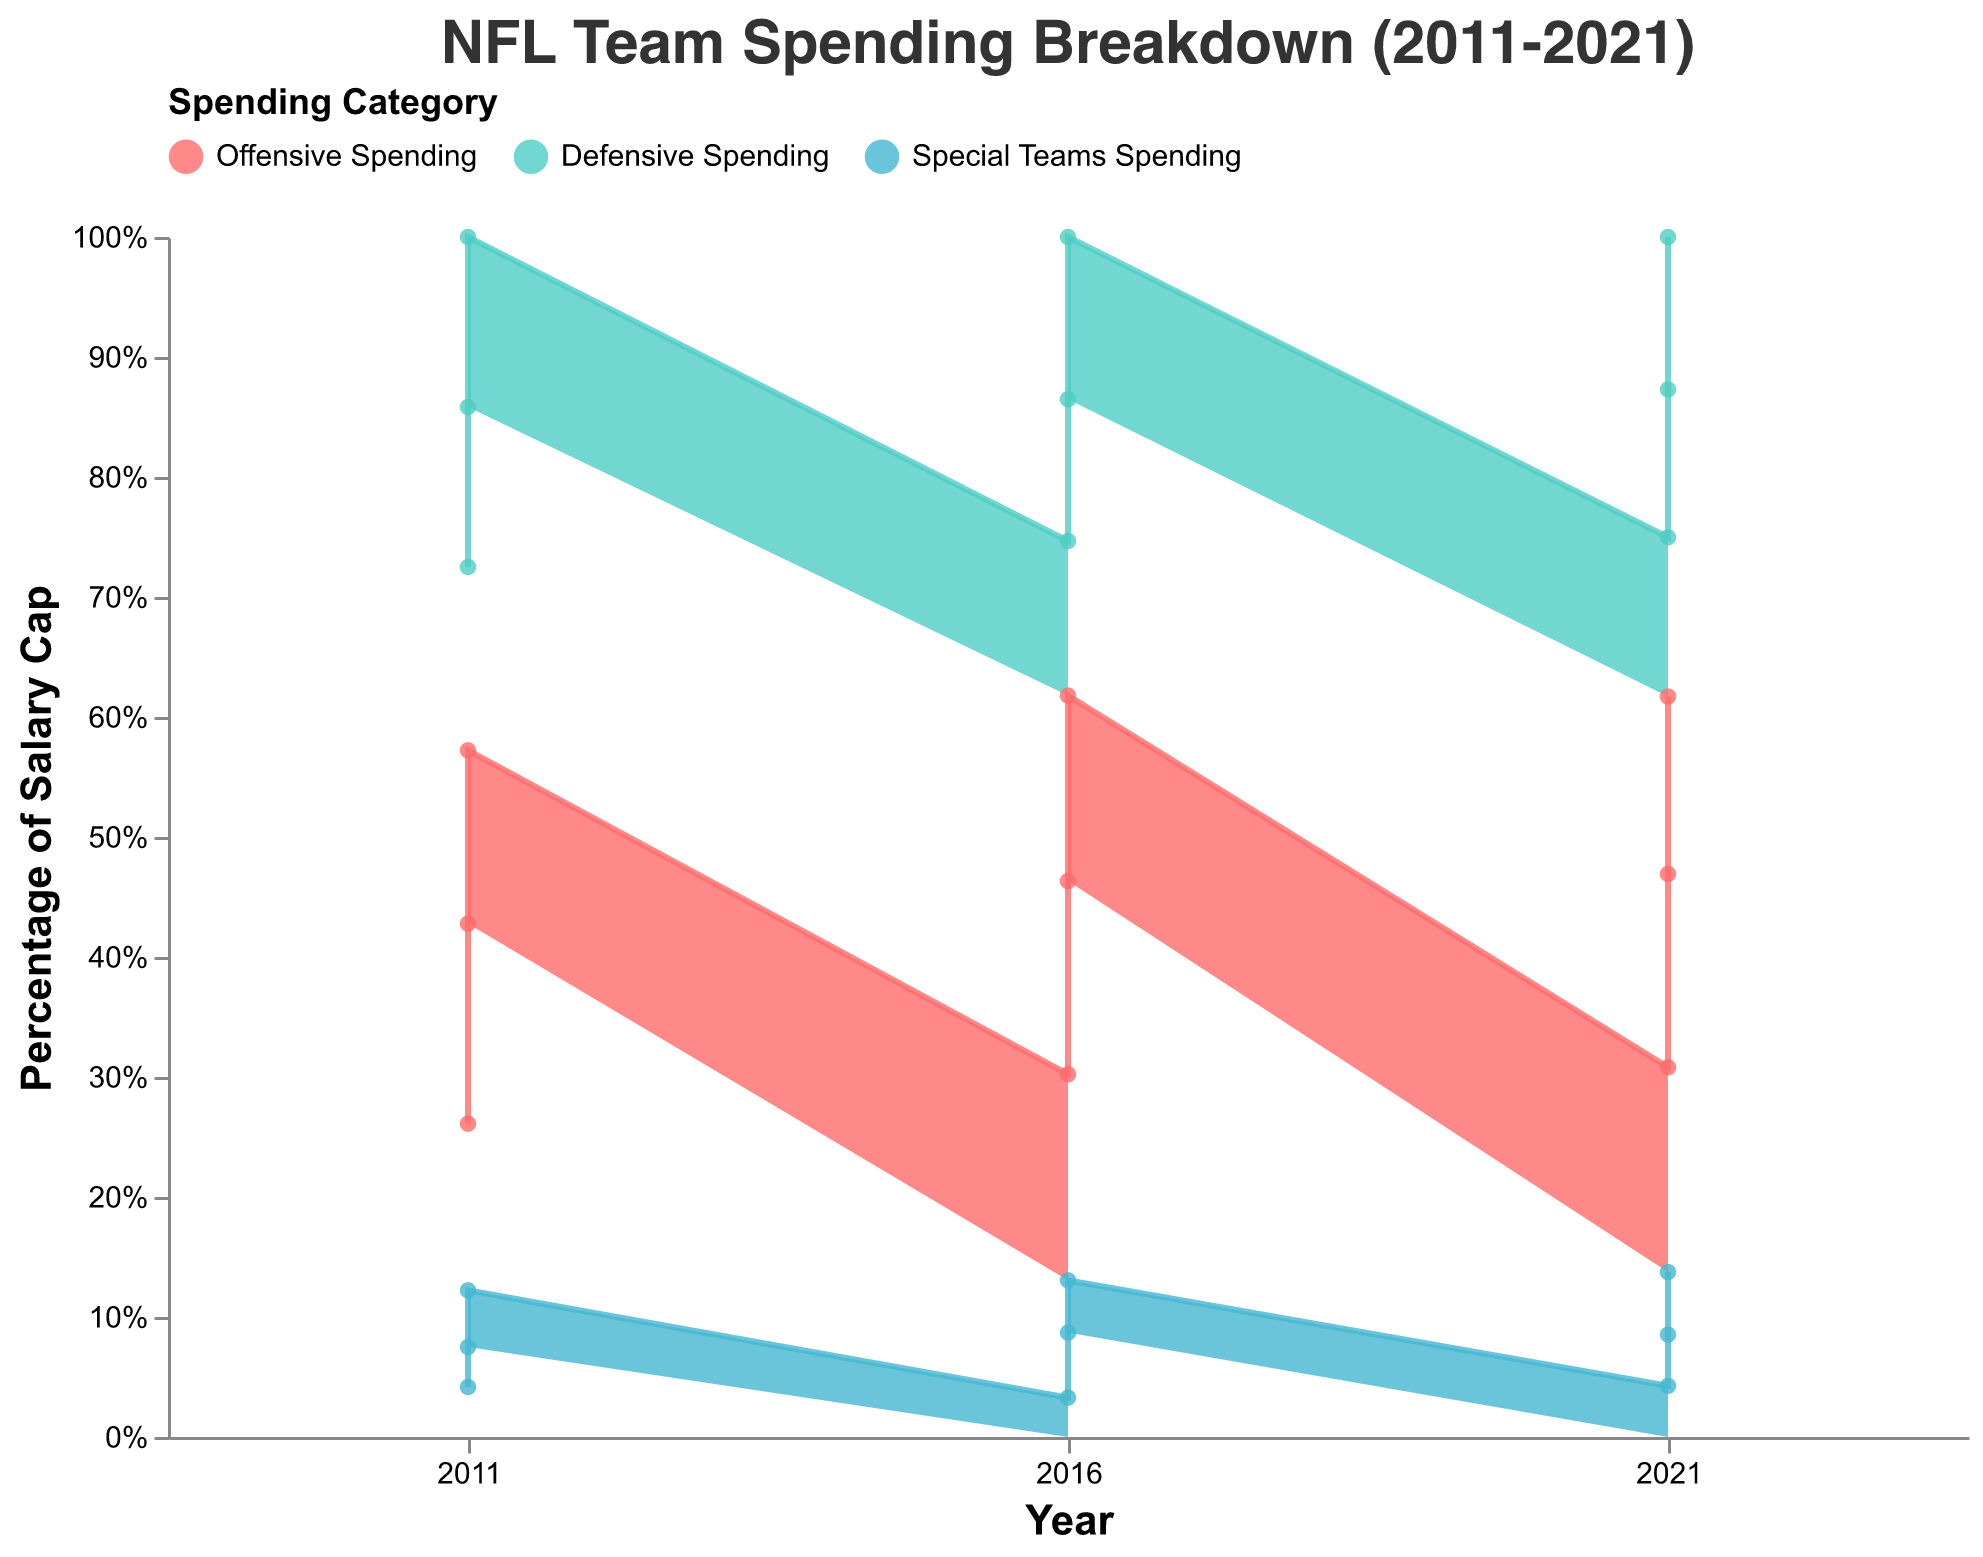What's the title of the chart? The title is typically displayed at the top of the chart. In this figure, the title is "NFL Team Spending Breakdown (2011-2021)."
Answer: NFL Team Spending Breakdown (2011-2021) What are the three spending categories shown in the chart? The legend indicates the three spending categories by color. The categories are Offensive Spending (red), Defensive Spending (green), and Special Teams Spending (blue).
Answer: Offensive Spending, Defensive Spending, Special Teams Spending Which team had the highest special teams spending in 2021? Look at the 2021 data points and compare the heights of the blue (Special Teams Spending) areas for each team. The highest point is for the Green Bay Packers.
Answer: Green Bay Packers How does the percentage of offensive spending change for Dallas Cowboys from 2011 to 2021? Identify the red (Offensive Spending) sections for the Dallas Cowboys in 2011 and 2021. The percentage of offensive spending increases from 41.67% in 2011 to 49.32% in 2021.
Answer: Increased Compare the percentage of defensive spending for the New England Patriots in 2011 and 2021. Which year had higher defensive spending? Measure the green (Defensive Spending) sections for the New England Patriots in 2011 and 2021. The defensive spending was higher in 2011 at 40% compared to 35.62% in 2021.
Answer: 2011 What is the total salary cap for all the teams in 2016? Sum the salary caps for all teams in 2016: 155270000 (Dallas Cowboys) + 155270000 (New England Patriots) + 155270000 (Green Bay Packers) = 465810000.
Answer: 465810000 Which team had the lowest offensive spending in 2016? Identify the red (Offensive Spending) sections for the teams in 2016. The New England Patriots had the lowest offensive spending at 75,000,000.
Answer: New England Patriots Did the spending proportion on special teams increase or decrease for the Green Bay Packers from 2016 to 2021? Compare the blue (Special Teams Spending) sections of 2016 and 2021 for the Green Bay Packers. The proportion increases from 13.05% in 2016 to 15.07% in 2021.
Answer: Increased What's the average total defensive spending in 2016 across all teams? Add the defensive spending for all teams in 2016: 60000000 + 55000000 + 63000000 = 178000000. Divide by 3 teams: 178000000 / 3 = 59333333.
Answer: 59333333 Which team had the highest overall spending in 2011 and on which category did they spend the most? Compare the total spending of each team in 2011 by examining the heights cumulatively. New England Patriots had the highest total spending, particularly spending the most on Offensive Spending.
Answer: New England Patriots, Offensive Spending 